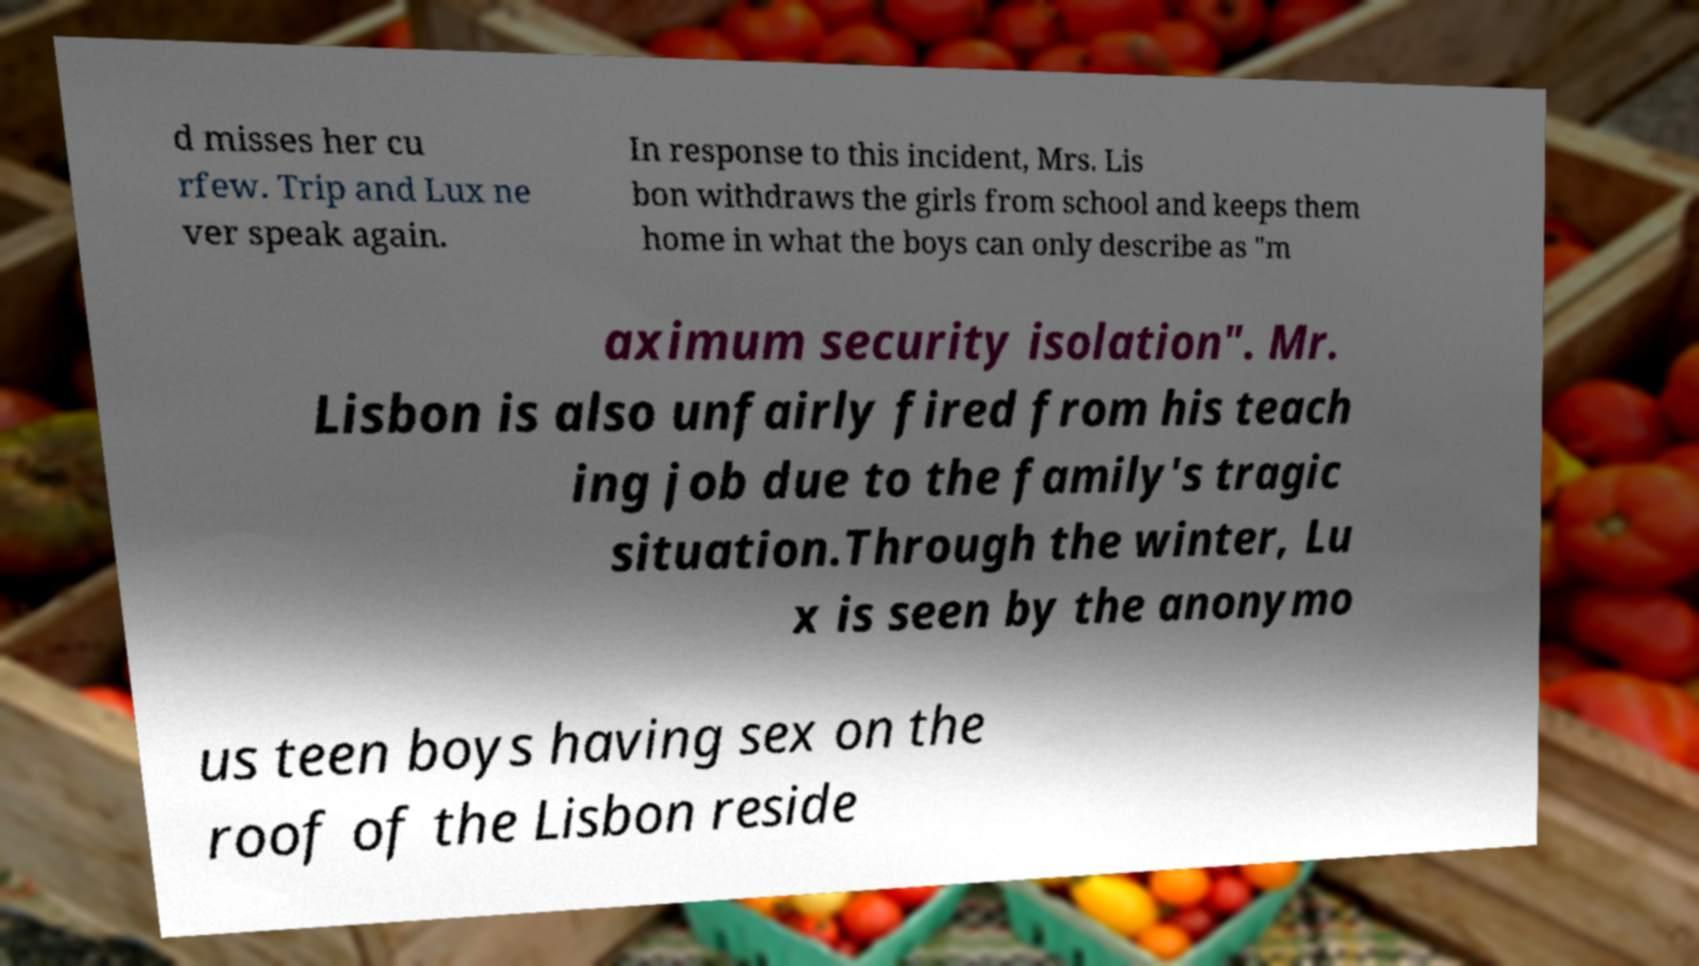Could you assist in decoding the text presented in this image and type it out clearly? d misses her cu rfew. Trip and Lux ne ver speak again. In response to this incident, Mrs. Lis bon withdraws the girls from school and keeps them home in what the boys can only describe as "m aximum security isolation". Mr. Lisbon is also unfairly fired from his teach ing job due to the family's tragic situation.Through the winter, Lu x is seen by the anonymo us teen boys having sex on the roof of the Lisbon reside 